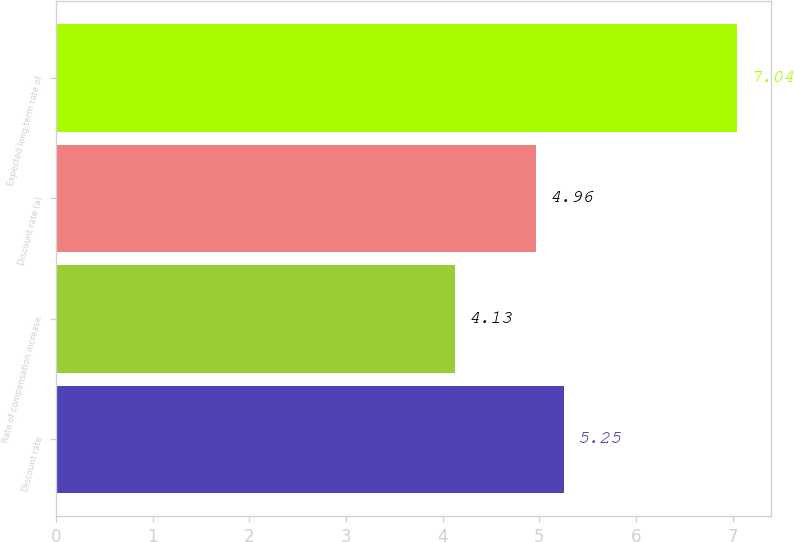Convert chart to OTSL. <chart><loc_0><loc_0><loc_500><loc_500><bar_chart><fcel>Discount rate<fcel>Rate of compensation increase<fcel>Discount rate (a)<fcel>Expected long-term rate of<nl><fcel>5.25<fcel>4.13<fcel>4.96<fcel>7.04<nl></chart> 